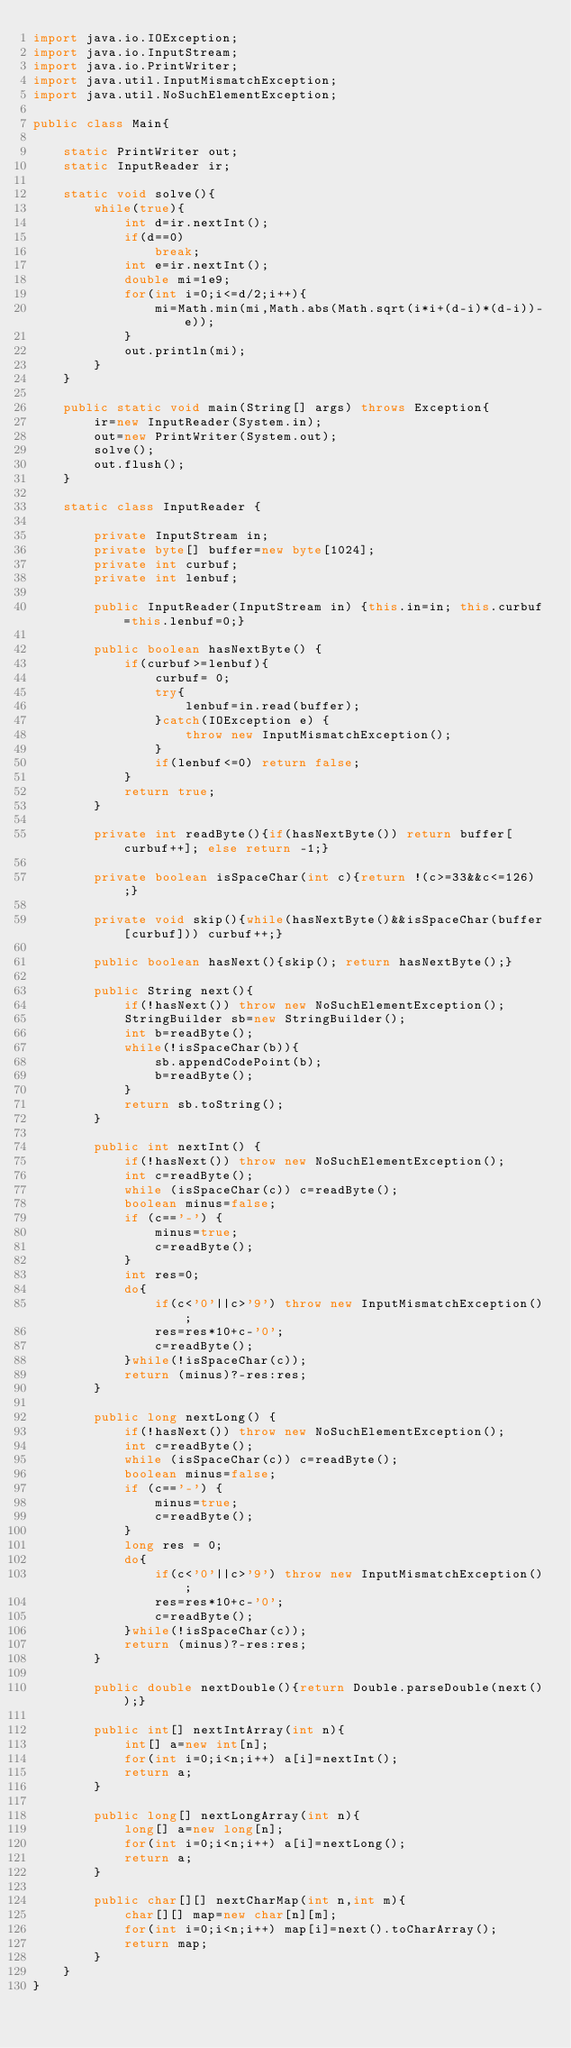Convert code to text. <code><loc_0><loc_0><loc_500><loc_500><_Java_>import java.io.IOException;
import java.io.InputStream;
import java.io.PrintWriter;
import java.util.InputMismatchException;
import java.util.NoSuchElementException;

public class Main{

	static PrintWriter out;
	static InputReader ir;

	static void solve(){
		while(true){
			int d=ir.nextInt();
			if(d==0)
				break;
			int e=ir.nextInt();
			double mi=1e9;
			for(int i=0;i<=d/2;i++){
				mi=Math.min(mi,Math.abs(Math.sqrt(i*i+(d-i)*(d-i))-e));
			}
			out.println(mi);
		}
	}

	public static void main(String[] args) throws Exception{
		ir=new InputReader(System.in);
		out=new PrintWriter(System.out);
		solve();
		out.flush();
	}

	static class InputReader {

		private InputStream in;
		private byte[] buffer=new byte[1024];
		private int curbuf;
		private int lenbuf;

		public InputReader(InputStream in) {this.in=in; this.curbuf=this.lenbuf=0;}

		public boolean hasNextByte() {
			if(curbuf>=lenbuf){
				curbuf= 0;
				try{
					lenbuf=in.read(buffer);
				}catch(IOException e) {
					throw new InputMismatchException();
				}
				if(lenbuf<=0) return false;
			}
			return true;
		}

		private int readByte(){if(hasNextByte()) return buffer[curbuf++]; else return -1;}

		private boolean isSpaceChar(int c){return !(c>=33&&c<=126);}

		private void skip(){while(hasNextByte()&&isSpaceChar(buffer[curbuf])) curbuf++;}

		public boolean hasNext(){skip(); return hasNextByte();}

		public String next(){
			if(!hasNext()) throw new NoSuchElementException();
			StringBuilder sb=new StringBuilder();
			int b=readByte();
			while(!isSpaceChar(b)){
				sb.appendCodePoint(b);
				b=readByte();
			}
			return sb.toString();
		}

		public int nextInt() {
			if(!hasNext()) throw new NoSuchElementException();
			int c=readByte();
			while (isSpaceChar(c)) c=readByte();
			boolean minus=false;
			if (c=='-') {
				minus=true;
				c=readByte();
			}
			int res=0;
			do{
				if(c<'0'||c>'9') throw new InputMismatchException();
				res=res*10+c-'0';
				c=readByte();
			}while(!isSpaceChar(c));
			return (minus)?-res:res;
		}

		public long nextLong() {
			if(!hasNext()) throw new NoSuchElementException();
			int c=readByte();
			while (isSpaceChar(c)) c=readByte();
			boolean minus=false;
			if (c=='-') {
				minus=true;
				c=readByte();
			}
			long res = 0;
			do{
				if(c<'0'||c>'9') throw new InputMismatchException();
				res=res*10+c-'0';
				c=readByte();
			}while(!isSpaceChar(c));
			return (minus)?-res:res;
		}

		public double nextDouble(){return Double.parseDouble(next());}

		public int[] nextIntArray(int n){
			int[] a=new int[n];
			for(int i=0;i<n;i++) a[i]=nextInt();
			return a;
		}

		public long[] nextLongArray(int n){
			long[] a=new long[n];
			for(int i=0;i<n;i++) a[i]=nextLong();
			return a;
		}

		public char[][] nextCharMap(int n,int m){
			char[][] map=new char[n][m];
			for(int i=0;i<n;i++) map[i]=next().toCharArray();
			return map;
		}
	}
}</code> 